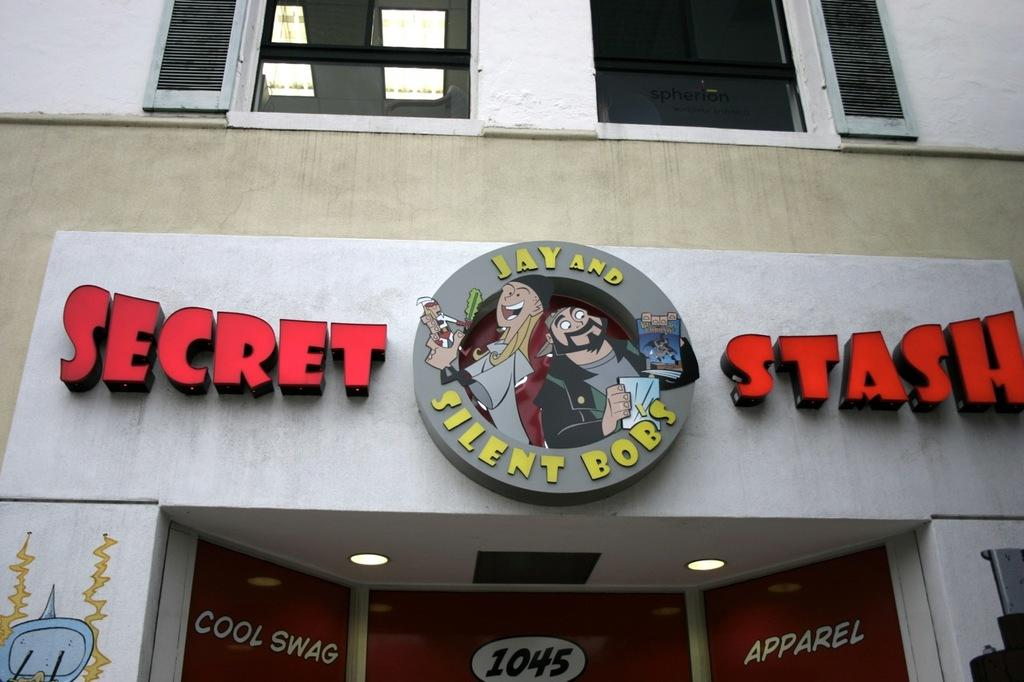<image>
Offer a succinct explanation of the picture presented. A shop's logo features the characters Jay and Silent Bob. 